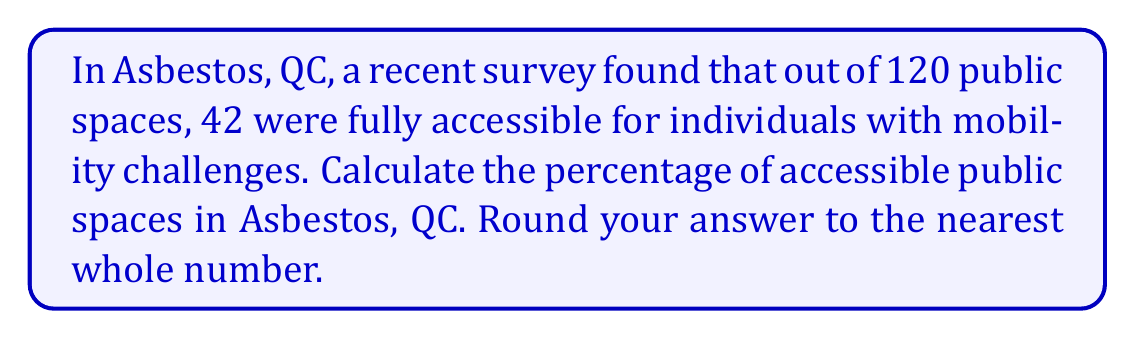Help me with this question. To calculate the percentage of accessible public spaces, we need to follow these steps:

1. Identify the total number of public spaces:
   Total spaces = 120

2. Identify the number of accessible spaces:
   Accessible spaces = 42

3. Use the formula for percentage:
   $$ \text{Percentage} = \frac{\text{Part}}{\text{Whole}} \times 100\% $$

4. Plug in the values:
   $$ \text{Percentage} = \frac{42}{120} \times 100\% $$

5. Simplify the fraction:
   $$ \text{Percentage} = 0.35 \times 100\% = 35\% $$

6. Round to the nearest whole number:
   35% rounds to 35%

Therefore, the percentage of accessible public spaces in Asbestos, QC is 35%.
Answer: 35% 